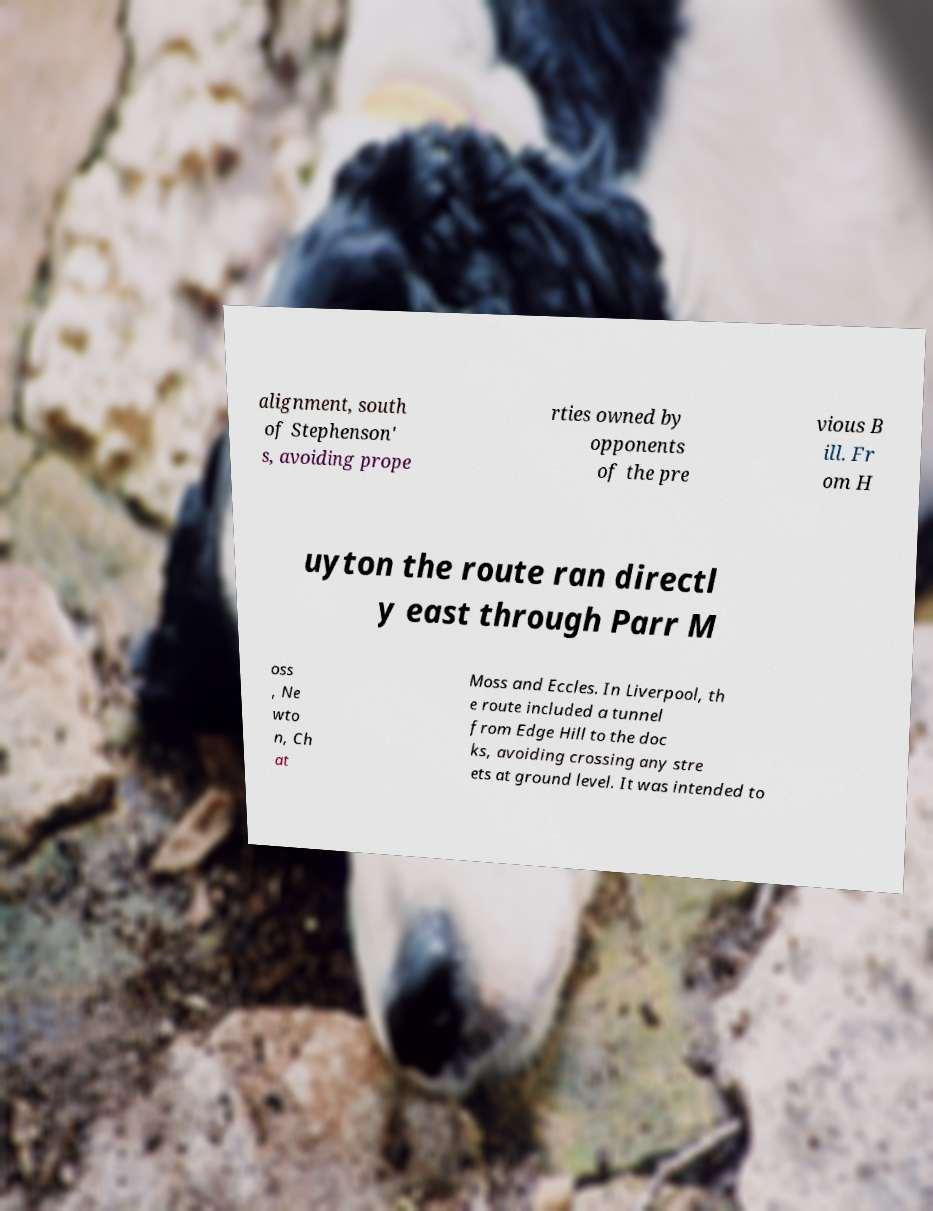I need the written content from this picture converted into text. Can you do that? alignment, south of Stephenson' s, avoiding prope rties owned by opponents of the pre vious B ill. Fr om H uyton the route ran directl y east through Parr M oss , Ne wto n, Ch at Moss and Eccles. In Liverpool, th e route included a tunnel from Edge Hill to the doc ks, avoiding crossing any stre ets at ground level. It was intended to 